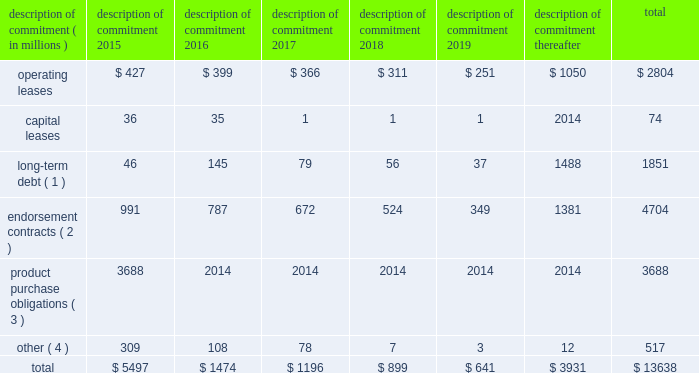Part ii on november 1 , 2011 , we entered into a committed credit facility agreement with a syndicate of banks which provides for up to $ 1 billion of borrowings with the option to increase borrowings to $ 1.5 billion with lender approval .
Following an extension agreement on september 17 , 2013 between the company and the syndicate of banks , the facility matures november 1 , 2017 , with a one-year extension option exercisable through october 31 , 2014 .
No amounts were outstanding under this facility as of may 31 , 2014 or 2013 .
We currently have long-term debt ratings of aa- and a1 from standard and poor 2019s corporation and moody 2019s investor services , respectively .
If our long- term debt rating were to decline , the facility fee and interest rate under our committed credit facility would increase .
Conversely , if our long-term debt rating were to improve , the facility fee and interest rate would decrease .
Changes in our long-term debt rating would not trigger acceleration of maturity of any then-outstanding borrowings or any future borrowings under the committed credit facility .
Under this committed revolving credit facility , we have agreed to various covenants .
These covenants include limits on our disposal of fixed assets , the amount of debt secured by liens we may incur , as well as a minimum capitalization ratio .
In the event we were to have any borrowings outstanding under this facility and failed to meet any covenant , and were unable to obtain a waiver from a majority of the banks in the syndicate , any borrowings would become immediately due and payable .
As of may 31 , 2014 , we were in full compliance with each of these covenants and believe it is unlikely we will fail to meet any of these covenants in the foreseeable future .
Liquidity is also provided by our $ 1 billion commercial paper program .
During the year ended may 31 , 2014 , we did not issue commercial paper , and as of may 31 , 2014 , there were no outstanding borrowings under this program .
We may continue to issue commercial paper or other debt securities during fiscal 2015 depending on general corporate needs .
We currently have short-term debt ratings of a1+ and p1 from standard and poor 2019s corporation and moody 2019s investor services , respectively .
As of may 31 , 2014 , we had cash , cash equivalents , and short-term investments totaling $ 5.1 billion , of which $ 2.5 billion was held by our foreign subsidiaries .
Cash equivalents and short-term investments consist primarily of deposits held at major banks , money market funds , commercial paper , corporate notes , u.s .
Treasury obligations , u.s .
Government sponsored enterprise obligations , and other investment grade fixed income securities .
Our fixed income investments are exposed to both credit and interest rate risk .
All of our investments are investment grade to minimize our credit risk .
While individual securities have varying durations , as of may 31 , 2014 the average duration of our short-term investments and cash equivalents portfolio was 126 days .
To date we have not experienced difficulty accessing the credit markets or incurred higher interest costs .
Future volatility in the capital markets , however , may increase costs associated with issuing commercial paper or other debt instruments or affect our ability to access those markets .
We believe that existing cash , cash equivalents , short-term investments , and cash generated by operations , together with access to external sources of funds as described above , will be sufficient to meet our domestic and foreign capital needs in the foreseeable future .
We utilize a variety of tax planning and financing strategies to manage our worldwide cash and deploy funds to locations where they are needed .
We routinely repatriate a portion of our foreign earnings for which u.s .
Taxes have previously been provided .
We also indefinitely reinvest a significant portion of our foreign earnings , and our current plans do not demonstrate a need to repatriate these earnings .
Should we require additional capital in the united states , we may elect to repatriate indefinitely reinvested foreign funds or raise capital in the united states through debt .
If we were to repatriate indefinitely reinvested foreign funds , we would be required to accrue and pay additional u.s .
Taxes less applicable foreign tax credits .
If we elect to raise capital in the united states through debt , we would incur additional interest expense .
Off-balance sheet arrangements in connection with various contracts and agreements , we routinely provide indemnification relating to the enforceability of intellectual property rights , coverage for legal issues that arise and other items where we are acting as the guarantor .
Currently , we have several such agreements in place .
However , based on our historical experience and the estimated probability of future loss , we have determined that the fair value of such indemnification is not material to our financial position or results of operations .
Contractual obligations our significant long-term contractual obligations as of may 31 , 2014 and significant endorsement contracts entered into through the date of this report are as follows: .
( 1 ) the cash payments due for long-term debt include estimated interest payments .
Estimates of interest payments are based on outstanding principal amounts , applicable fixed interest rates or currently effective interest rates as of may 31 , 2014 ( if variable ) , timing of scheduled payments , and the term of the debt obligations .
( 2 ) the amounts listed for endorsement contracts represent approximate amounts of base compensation and minimum guaranteed royalty fees we are obligated to pay athlete and sport team endorsers of our products .
Actual payments under some contracts may be higher than the amounts listed as these contracts provide for bonuses to be paid to the endorsers based upon athletic achievements and/or royalties on product sales in future periods .
Actual payments under some contracts may also be lower as these contracts include provisions for reduced payments if athletic performance declines in future periods .
In addition to the cash payments , we are obligated to furnish our endorsers with nike product for their use .
It is not possible to determine how much we will spend on this product on an annual basis as the contracts generally do not stipulate a specific amount of cash to be spent on the product .
The amount of product provided to the endorsers will depend on many factors , including general playing conditions , the number of sporting events in which they participate , and our own decisions regarding product and marketing initiatives .
In addition , the costs to design , develop , source , and purchase the products furnished to the endorsers are incurred over a period of time and are not necessarily tracked separately from similar costs incurred for products sold to customers .
( 3 ) we generally order product at least four to five months in advance of sale based primarily on futures orders received from customers .
The amounts listed for product purchase obligations represent agreements ( including open purchase orders ) to purchase products in the ordinary course of business that are enforceable and legally binding and that specify all significant terms .
In some cases , prices are subject to change throughout the production process .
The reported amounts exclude product purchase liabilities included in accounts payable on the consolidated balance sheet as of may 31 , 2014 .
( 4 ) other amounts primarily include service and marketing commitments made in the ordinary course of business .
The amounts represent the minimum payments required by legally binding contracts and agreements that specify all significant terms , including open purchase orders for non-product purchases .
The reported amounts exclude those liabilities included in accounts payable or accrued liabilities on the consolidated balance sheet as of may 31 , 2014 .
Nike , inc .
2014 annual report and notice of annual meeting 79 .
What percentage of operating leases are due after 2019? 
Computations: (1050 / 2804)
Answer: 0.37447. 